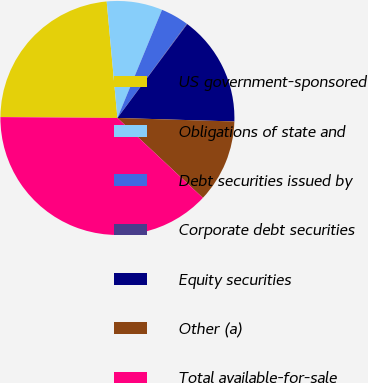Convert chart. <chart><loc_0><loc_0><loc_500><loc_500><pie_chart><fcel>US government-sponsored<fcel>Obligations of state and<fcel>Debt securities issued by<fcel>Corporate debt securities<fcel>Equity securities<fcel>Other (a)<fcel>Total available-for-sale<nl><fcel>23.42%<fcel>7.69%<fcel>3.88%<fcel>0.07%<fcel>15.3%<fcel>11.49%<fcel>38.15%<nl></chart> 